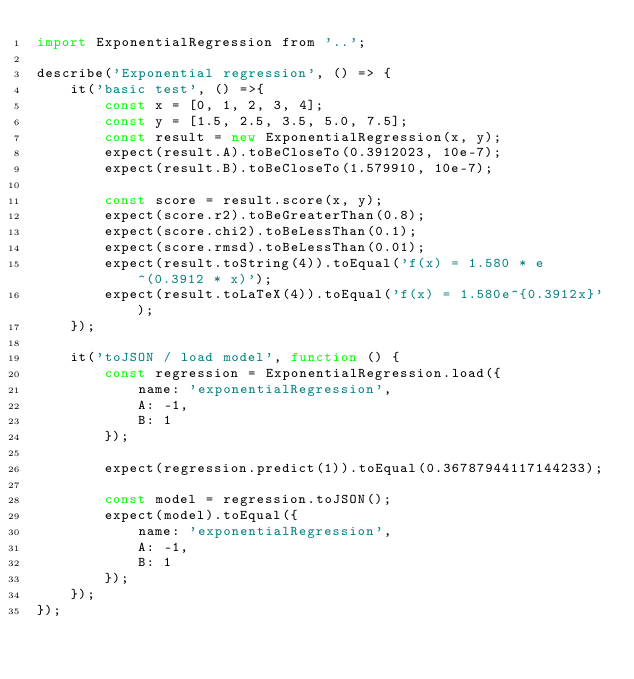<code> <loc_0><loc_0><loc_500><loc_500><_JavaScript_>import ExponentialRegression from '..';

describe('Exponential regression', () => {
    it('basic test', () =>{
        const x = [0, 1, 2, 3, 4];
        const y = [1.5, 2.5, 3.5, 5.0, 7.5];
        const result = new ExponentialRegression(x, y);
        expect(result.A).toBeCloseTo(0.3912023, 10e-7);
        expect(result.B).toBeCloseTo(1.579910, 10e-7);

        const score = result.score(x, y);
        expect(score.r2).toBeGreaterThan(0.8);
        expect(score.chi2).toBeLessThan(0.1);
        expect(score.rmsd).toBeLessThan(0.01);
        expect(result.toString(4)).toEqual('f(x) = 1.580 * e^(0.3912 * x)');
        expect(result.toLaTeX(4)).toEqual('f(x) = 1.580e^{0.3912x}');
    });

    it('toJSON / load model', function () {
        const regression = ExponentialRegression.load({
            name: 'exponentialRegression',
            A: -1,
            B: 1
        });

        expect(regression.predict(1)).toEqual(0.36787944117144233);

        const model = regression.toJSON();
        expect(model).toEqual({
            name: 'exponentialRegression',
            A: -1,
            B: 1
        });
    });
});
</code> 